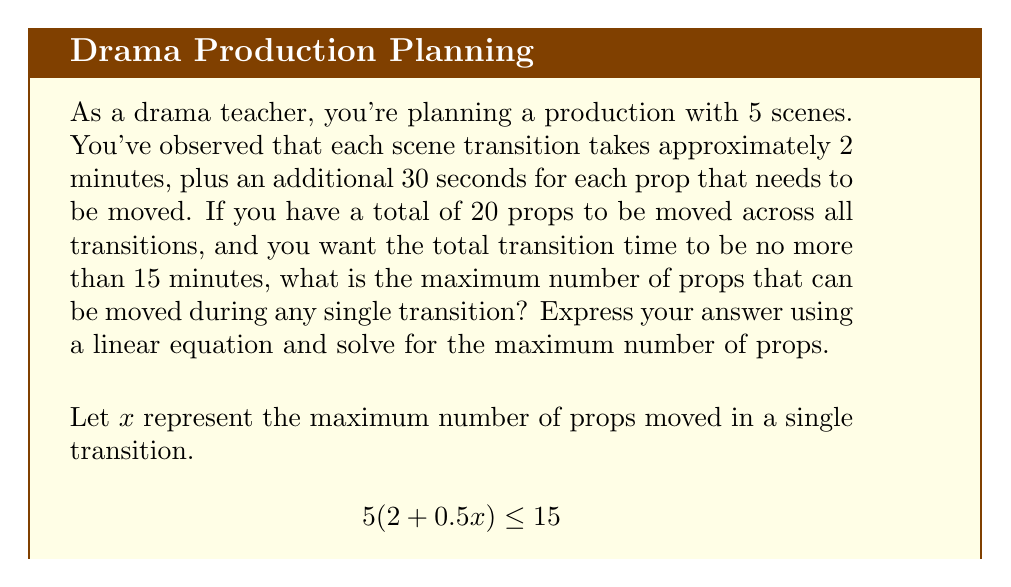Provide a solution to this math problem. Let's break this problem down step-by-step:

1) We start with the linear inequality:
   $$5(2 + 0.5x) \leq 15$$

2) First, let's distribute the 5:
   $$10 + 2.5x \leq 15$$

3) Now, subtract 10 from both sides:
   $$2.5x \leq 5$$

4) Divide both sides by 2.5:
   $$x \leq 2$$

5) Since $x$ represents the number of props and must be a whole number, the maximum value for $x$ is 2.

6) To verify, let's plug this back into our original inequality:
   $$5(2 + 0.5(2)) \leq 15$$
   $$5(2 + 1) \leq 15$$
   $$5(3) \leq 15$$
   $$15 \leq 15$$

This confirms that 2 is indeed the maximum number of props that can be moved during any single transition while keeping the total transition time at or below 15 minutes.
Answer: The maximum number of props that can be moved during any single transition is 2. 